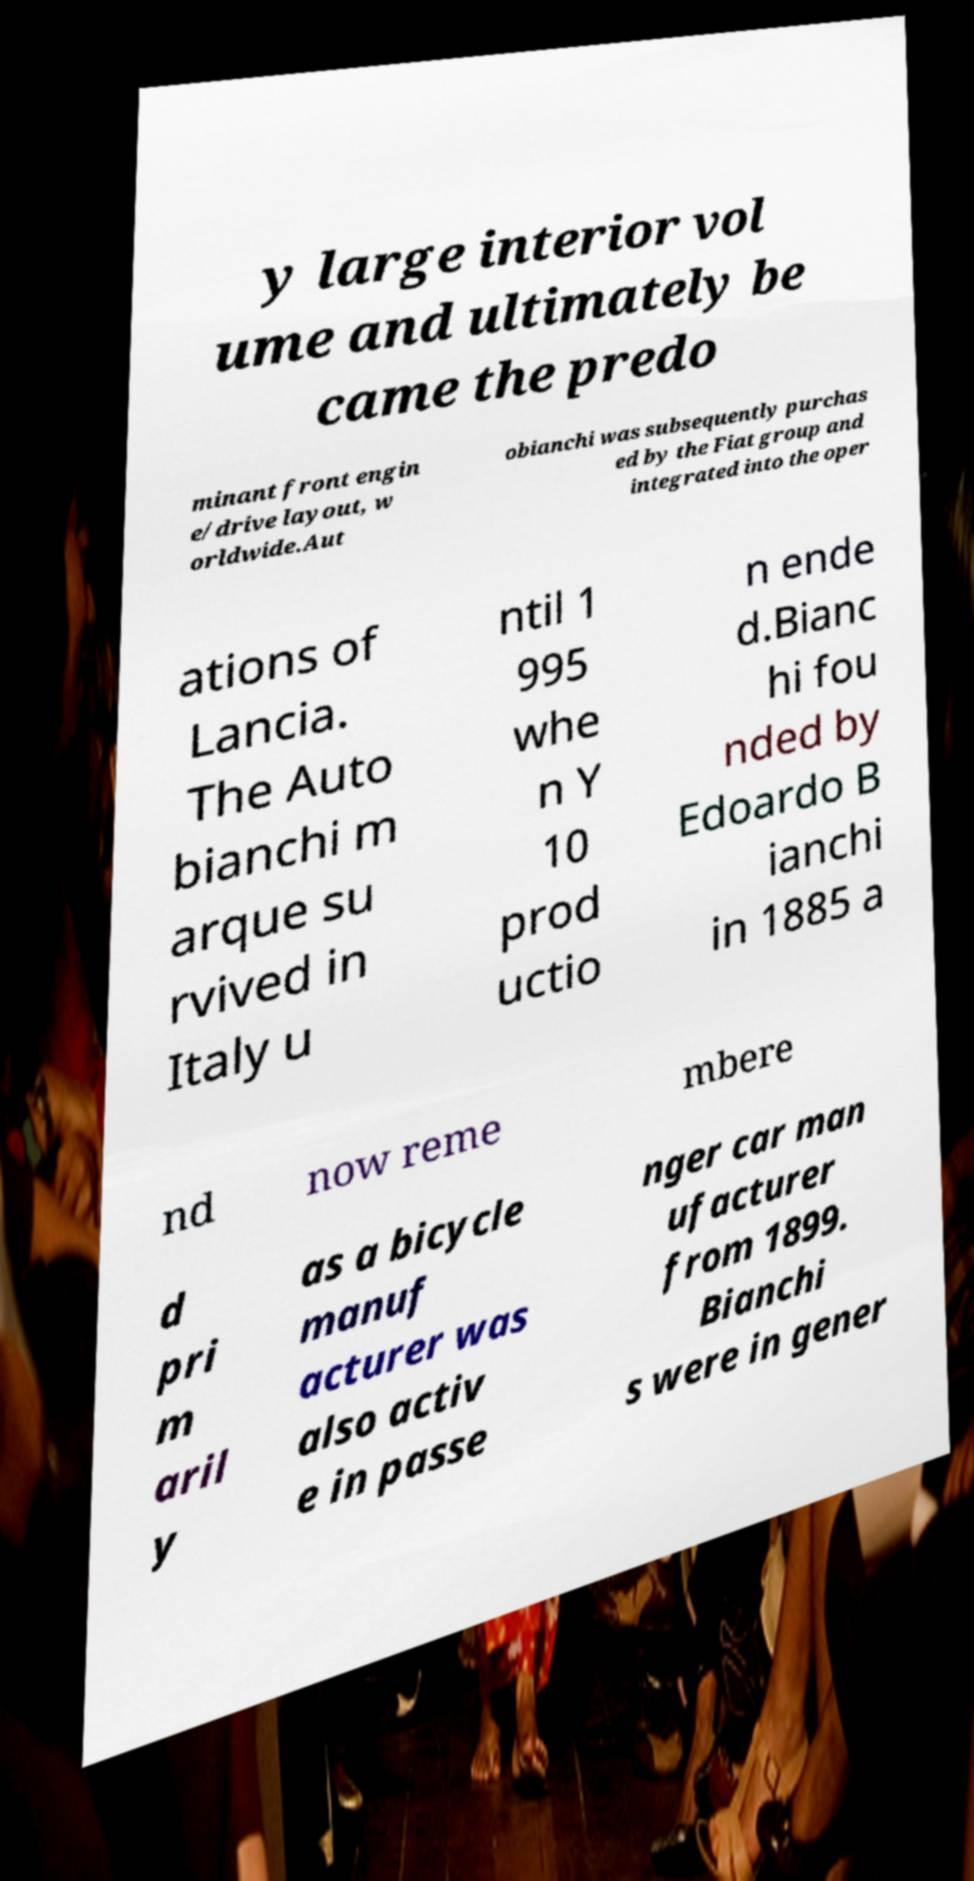There's text embedded in this image that I need extracted. Can you transcribe it verbatim? y large interior vol ume and ultimately be came the predo minant front engin e/drive layout, w orldwide.Aut obianchi was subsequently purchas ed by the Fiat group and integrated into the oper ations of Lancia. The Auto bianchi m arque su rvived in Italy u ntil 1 995 whe n Y 10 prod uctio n ende d.Bianc hi fou nded by Edoardo B ianchi in 1885 a nd now reme mbere d pri m aril y as a bicycle manuf acturer was also activ e in passe nger car man ufacturer from 1899. Bianchi s were in gener 